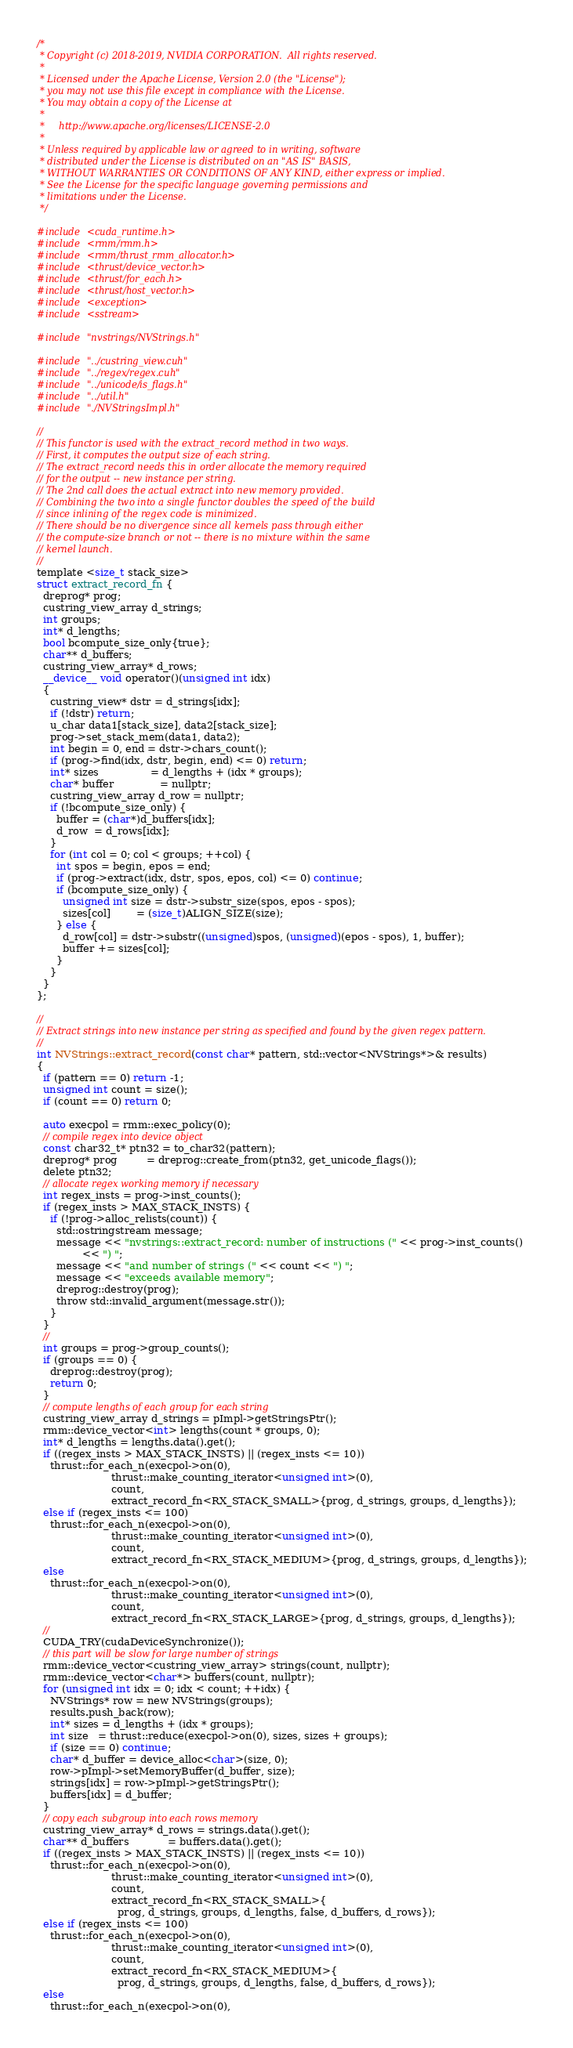<code> <loc_0><loc_0><loc_500><loc_500><_Cuda_>/*
 * Copyright (c) 2018-2019, NVIDIA CORPORATION.  All rights reserved.
 *
 * Licensed under the Apache License, Version 2.0 (the "License");
 * you may not use this file except in compliance with the License.
 * You may obtain a copy of the License at
 *
 *     http://www.apache.org/licenses/LICENSE-2.0
 *
 * Unless required by applicable law or agreed to in writing, software
 * distributed under the License is distributed on an "AS IS" BASIS,
 * WITHOUT WARRANTIES OR CONDITIONS OF ANY KIND, either express or implied.
 * See the License for the specific language governing permissions and
 * limitations under the License.
 */

#include <cuda_runtime.h>
#include <rmm/rmm.h>
#include <rmm/thrust_rmm_allocator.h>
#include <thrust/device_vector.h>
#include <thrust/for_each.h>
#include <thrust/host_vector.h>
#include <exception>
#include <sstream>

#include "nvstrings/NVStrings.h"

#include "../custring_view.cuh"
#include "../regex/regex.cuh"
#include "../unicode/is_flags.h"
#include "../util.h"
#include "./NVStringsImpl.h"

//
// This functor is used with the extract_record method in two ways.
// First, it computes the output size of each string.
// The extract_record needs this in order allocate the memory required
// for the output -- new instance per string.
// The 2nd call does the actual extract into new memory provided.
// Combining the two into a single functor doubles the speed of the build
// since inlining of the regex code is minimized.
// There should be no divergence since all kernels pass through either
// the compute-size branch or not -- there is no mixture within the same
// kernel launch.
//
template <size_t stack_size>
struct extract_record_fn {
  dreprog* prog;
  custring_view_array d_strings;
  int groups;
  int* d_lengths;
  bool bcompute_size_only{true};
  char** d_buffers;
  custring_view_array* d_rows;
  __device__ void operator()(unsigned int idx)
  {
    custring_view* dstr = d_strings[idx];
    if (!dstr) return;
    u_char data1[stack_size], data2[stack_size];
    prog->set_stack_mem(data1, data2);
    int begin = 0, end = dstr->chars_count();
    if (prog->find(idx, dstr, begin, end) <= 0) return;
    int* sizes                = d_lengths + (idx * groups);
    char* buffer              = nullptr;
    custring_view_array d_row = nullptr;
    if (!bcompute_size_only) {
      buffer = (char*)d_buffers[idx];
      d_row  = d_rows[idx];
    }
    for (int col = 0; col < groups; ++col) {
      int spos = begin, epos = end;
      if (prog->extract(idx, dstr, spos, epos, col) <= 0) continue;
      if (bcompute_size_only) {
        unsigned int size = dstr->substr_size(spos, epos - spos);
        sizes[col]        = (size_t)ALIGN_SIZE(size);
      } else {
        d_row[col] = dstr->substr((unsigned)spos, (unsigned)(epos - spos), 1, buffer);
        buffer += sizes[col];
      }
    }
  }
};

//
// Extract strings into new instance per string as specified and found by the given regex pattern.
//
int NVStrings::extract_record(const char* pattern, std::vector<NVStrings*>& results)
{
  if (pattern == 0) return -1;
  unsigned int count = size();
  if (count == 0) return 0;

  auto execpol = rmm::exec_policy(0);
  // compile regex into device object
  const char32_t* ptn32 = to_char32(pattern);
  dreprog* prog         = dreprog::create_from(ptn32, get_unicode_flags());
  delete ptn32;
  // allocate regex working memory if necessary
  int regex_insts = prog->inst_counts();
  if (regex_insts > MAX_STACK_INSTS) {
    if (!prog->alloc_relists(count)) {
      std::ostringstream message;
      message << "nvstrings::extract_record: number of instructions (" << prog->inst_counts()
              << ") ";
      message << "and number of strings (" << count << ") ";
      message << "exceeds available memory";
      dreprog::destroy(prog);
      throw std::invalid_argument(message.str());
    }
  }
  //
  int groups = prog->group_counts();
  if (groups == 0) {
    dreprog::destroy(prog);
    return 0;
  }
  // compute lengths of each group for each string
  custring_view_array d_strings = pImpl->getStringsPtr();
  rmm::device_vector<int> lengths(count * groups, 0);
  int* d_lengths = lengths.data().get();
  if ((regex_insts > MAX_STACK_INSTS) || (regex_insts <= 10))
    thrust::for_each_n(execpol->on(0),
                       thrust::make_counting_iterator<unsigned int>(0),
                       count,
                       extract_record_fn<RX_STACK_SMALL>{prog, d_strings, groups, d_lengths});
  else if (regex_insts <= 100)
    thrust::for_each_n(execpol->on(0),
                       thrust::make_counting_iterator<unsigned int>(0),
                       count,
                       extract_record_fn<RX_STACK_MEDIUM>{prog, d_strings, groups, d_lengths});
  else
    thrust::for_each_n(execpol->on(0),
                       thrust::make_counting_iterator<unsigned int>(0),
                       count,
                       extract_record_fn<RX_STACK_LARGE>{prog, d_strings, groups, d_lengths});
  //
  CUDA_TRY(cudaDeviceSynchronize());
  // this part will be slow for large number of strings
  rmm::device_vector<custring_view_array> strings(count, nullptr);
  rmm::device_vector<char*> buffers(count, nullptr);
  for (unsigned int idx = 0; idx < count; ++idx) {
    NVStrings* row = new NVStrings(groups);
    results.push_back(row);
    int* sizes = d_lengths + (idx * groups);
    int size   = thrust::reduce(execpol->on(0), sizes, sizes + groups);
    if (size == 0) continue;
    char* d_buffer = device_alloc<char>(size, 0);
    row->pImpl->setMemoryBuffer(d_buffer, size);
    strings[idx] = row->pImpl->getStringsPtr();
    buffers[idx] = d_buffer;
  }
  // copy each subgroup into each rows memory
  custring_view_array* d_rows = strings.data().get();
  char** d_buffers            = buffers.data().get();
  if ((regex_insts > MAX_STACK_INSTS) || (regex_insts <= 10))
    thrust::for_each_n(execpol->on(0),
                       thrust::make_counting_iterator<unsigned int>(0),
                       count,
                       extract_record_fn<RX_STACK_SMALL>{
                         prog, d_strings, groups, d_lengths, false, d_buffers, d_rows});
  else if (regex_insts <= 100)
    thrust::for_each_n(execpol->on(0),
                       thrust::make_counting_iterator<unsigned int>(0),
                       count,
                       extract_record_fn<RX_STACK_MEDIUM>{
                         prog, d_strings, groups, d_lengths, false, d_buffers, d_rows});
  else
    thrust::for_each_n(execpol->on(0),</code> 